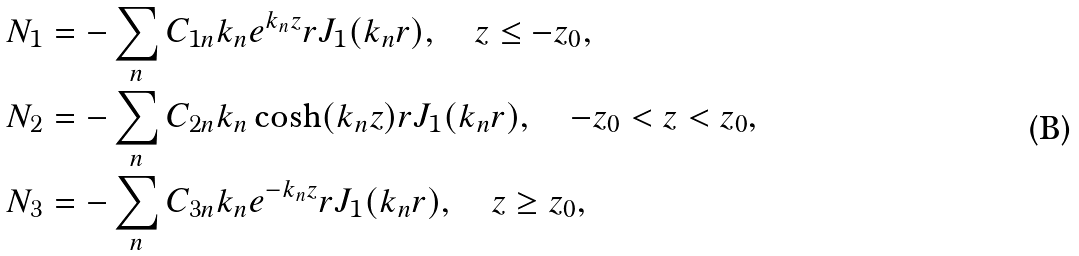Convert formula to latex. <formula><loc_0><loc_0><loc_500><loc_500>N _ { 1 } & = - \sum _ { n } C _ { 1 n } k _ { n } e ^ { k _ { n } z } r J _ { 1 } ( k _ { n } r ) , \quad z \leq - z _ { 0 } , \\ N _ { 2 } & = - \sum _ { n } C _ { 2 n } k _ { n } \cosh ( k _ { n } z ) r J _ { 1 } ( k _ { n } r ) , \quad - z _ { 0 } < z < z _ { 0 } , \\ N _ { 3 } & = - \sum _ { n } C _ { 3 n } k _ { n } e ^ { - k _ { n } z } r J _ { 1 } ( k _ { n } r ) , \quad z \geq z _ { 0 } ,</formula> 